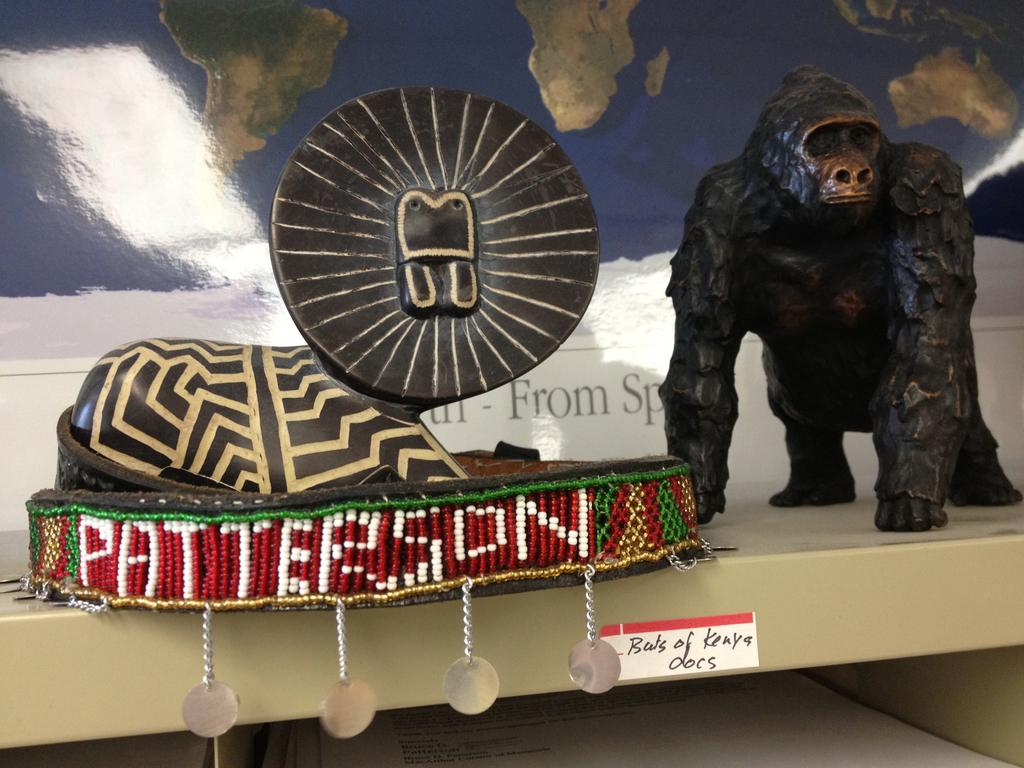What is the main subject in the center of the image? There is a statue in the center of the image. Are there any other statues visible in the image? Yes, there is a monkey statue on the right side of the image. What can be seen in the background of the image? There is a map in the background of the image. Is there any quicksand surrounding the statues in the image? There is no quicksand present in the image. What type of ear is visible on the monkey statue? The monkey statue does not have an ear; it is a statue and does not have body parts like a living creature. 